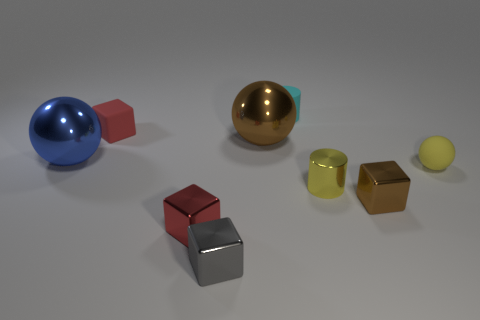What number of objects are cyan objects or tiny blocks?
Provide a succinct answer. 5. What number of other objects are the same shape as the small yellow metal thing?
Ensure brevity in your answer.  1. Is the material of the brown thing in front of the small yellow sphere the same as the gray block left of the yellow cylinder?
Keep it short and to the point. Yes. There is a small object that is both behind the yellow cylinder and to the right of the cyan rubber cylinder; what is its shape?
Your answer should be very brief. Sphere. Is there anything else that has the same material as the small yellow sphere?
Offer a very short reply. Yes. The small cube that is both behind the small red metal cube and in front of the small yellow matte object is made of what material?
Provide a short and direct response. Metal. What is the shape of the red thing that is the same material as the gray object?
Give a very brief answer. Cube. Are there any other things that have the same color as the tiny rubber ball?
Your response must be concise. Yes. Are there more cubes that are behind the small red metallic cube than tiny matte cylinders?
Offer a very short reply. Yes. What is the brown ball made of?
Your answer should be very brief. Metal. 